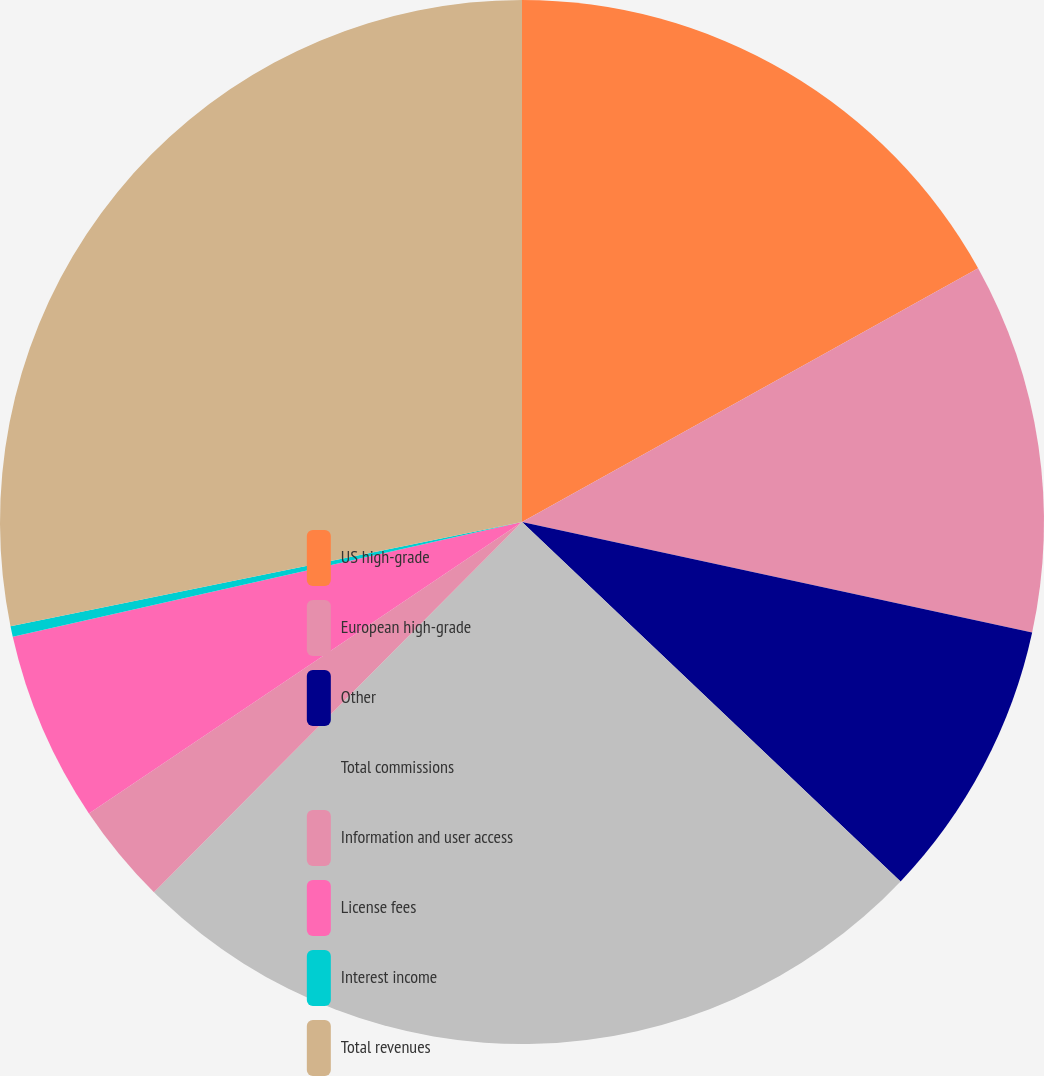<chart> <loc_0><loc_0><loc_500><loc_500><pie_chart><fcel>US high-grade<fcel>European high-grade<fcel>Other<fcel>Total commissions<fcel>Information and user access<fcel>License fees<fcel>Interest income<fcel>Total revenues<nl><fcel>16.92%<fcel>11.48%<fcel>8.69%<fcel>25.37%<fcel>3.12%<fcel>5.9%<fcel>0.33%<fcel>28.2%<nl></chart> 